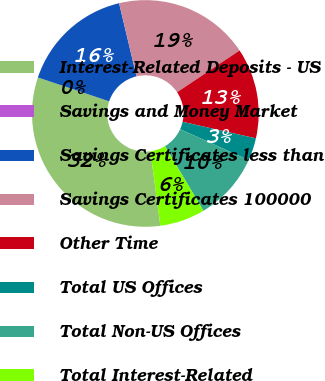Convert chart to OTSL. <chart><loc_0><loc_0><loc_500><loc_500><pie_chart><fcel>Interest-Related Deposits - US<fcel>Savings and Money Market<fcel>Savings Certificates less than<fcel>Savings Certificates 100000<fcel>Other Time<fcel>Total US Offices<fcel>Total Non-US Offices<fcel>Total Interest-Related<nl><fcel>32.26%<fcel>0.0%<fcel>16.13%<fcel>19.35%<fcel>12.9%<fcel>3.23%<fcel>9.68%<fcel>6.45%<nl></chart> 